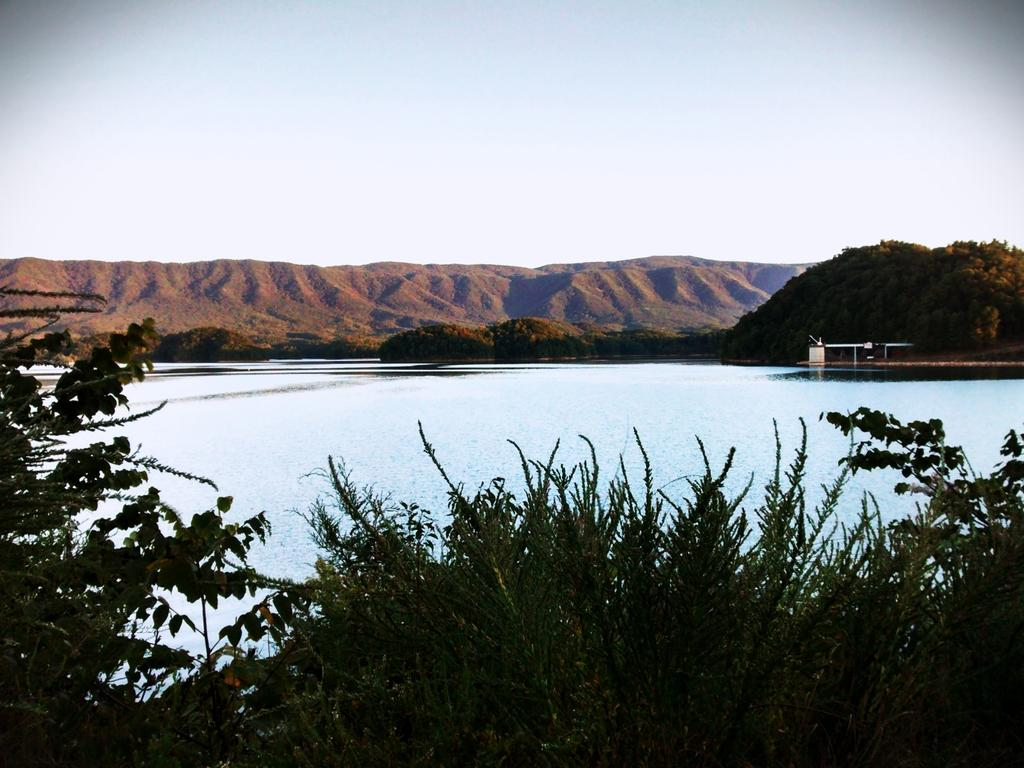What type of living organisms can be seen in the image? Plants and trees are visible in the image. What can be seen in the foreground of the image? There is water visible in the image. What is visible in the background of the image? Trees, hills, and the sky are visible in the background of the image. How many cars can be seen driving through the sky in the image? There are no cars visible in the image, and cars cannot drive through the sky. 